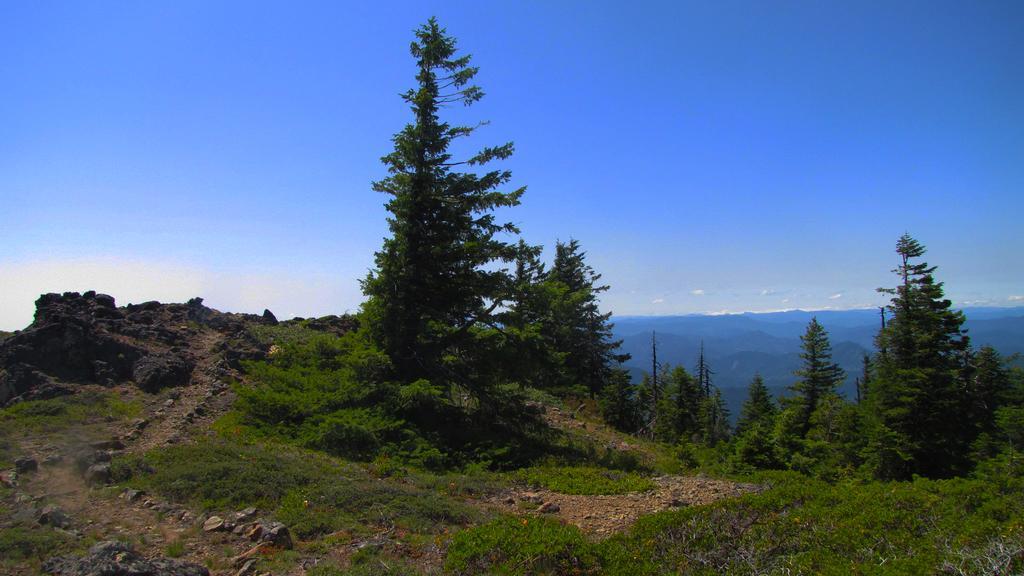How would you summarize this image in a sentence or two? In this image we can see trees, plants, grass and stones on the ground. In the background we can see hills and clouds in the sky. 